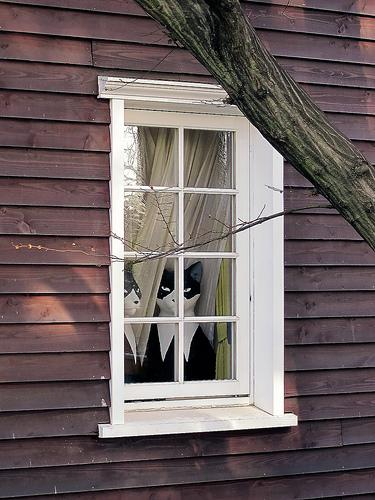Detail the central element in the image and its surroundings. The main focus of the image is a black and white toy cat positioned near a window with white curtains and an outdoor tree trunk. Write a short statement about the main element in the image and what it is surrounded by. A black and white toy cat appears to be looking out a window framed by white curtains and a tree trunk outside. Describe the key subject and its setting in the image. A black and white toy cat is the main focus, sitting near a white-curtained window with a tree trunk in the background. State the primary subject of the image and the context it is in. The image features a black and white toy cat sitting by a window with white curtains and a tree trunk outside. Identify the primary object in the image along with its surroundings. A black and white toy cat is in front of a window with white curtains and a tree trunk outside. Summarize the main point of interest in the image and its environment. A black and white toy cat is positioned near a window with white curtains and a nearby tree visible. Provide a brief description of the main focal point in the image. A black and white toy cat is sitting by the window with a white curtain and a large tree trunk visible outside. Briefly describe the main object in the picture and its setting. A black and white toy cat sits by a white-curtained window with a tree trunk outside. 